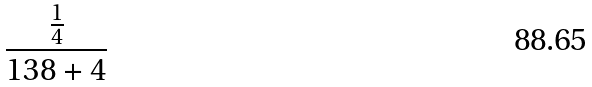<formula> <loc_0><loc_0><loc_500><loc_500>\frac { \frac { 1 } { 4 } } { 1 3 8 + 4 }</formula> 